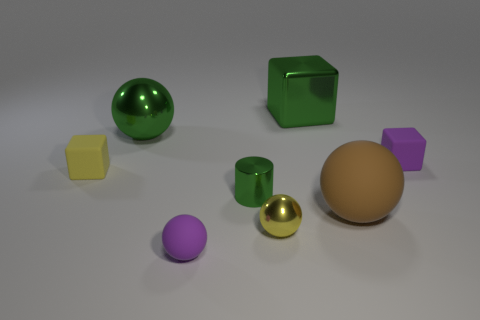Can you tell me which objects are spheres in this image? Certainly! In the image, there are three spheres. One is green, another is purple, and the third one is gold in color. 